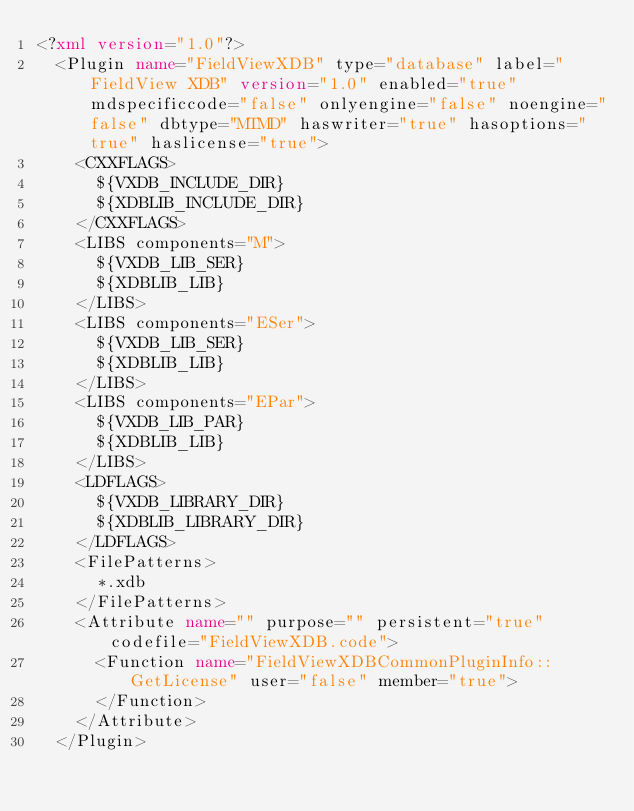<code> <loc_0><loc_0><loc_500><loc_500><_XML_><?xml version="1.0"?>
  <Plugin name="FieldViewXDB" type="database" label="FieldView XDB" version="1.0" enabled="true" mdspecificcode="false" onlyengine="false" noengine="false" dbtype="MTMD" haswriter="true" hasoptions="true" haslicense="true">
    <CXXFLAGS>
      ${VXDB_INCLUDE_DIR}
      ${XDBLIB_INCLUDE_DIR}
    </CXXFLAGS>
    <LIBS components="M">
      ${VXDB_LIB_SER}
      ${XDBLIB_LIB}
    </LIBS>
    <LIBS components="ESer">
      ${VXDB_LIB_SER}
      ${XDBLIB_LIB}
    </LIBS>
    <LIBS components="EPar">
      ${VXDB_LIB_PAR}
      ${XDBLIB_LIB}
    </LIBS>
    <LDFLAGS>
      ${VXDB_LIBRARY_DIR}
      ${XDBLIB_LIBRARY_DIR}
    </LDFLAGS>
    <FilePatterns>
      *.xdb
    </FilePatterns>
    <Attribute name="" purpose="" persistent="true" codefile="FieldViewXDB.code">
      <Function name="FieldViewXDBCommonPluginInfo::GetLicense" user="false" member="true">
      </Function>
    </Attribute>
  </Plugin>
</code> 